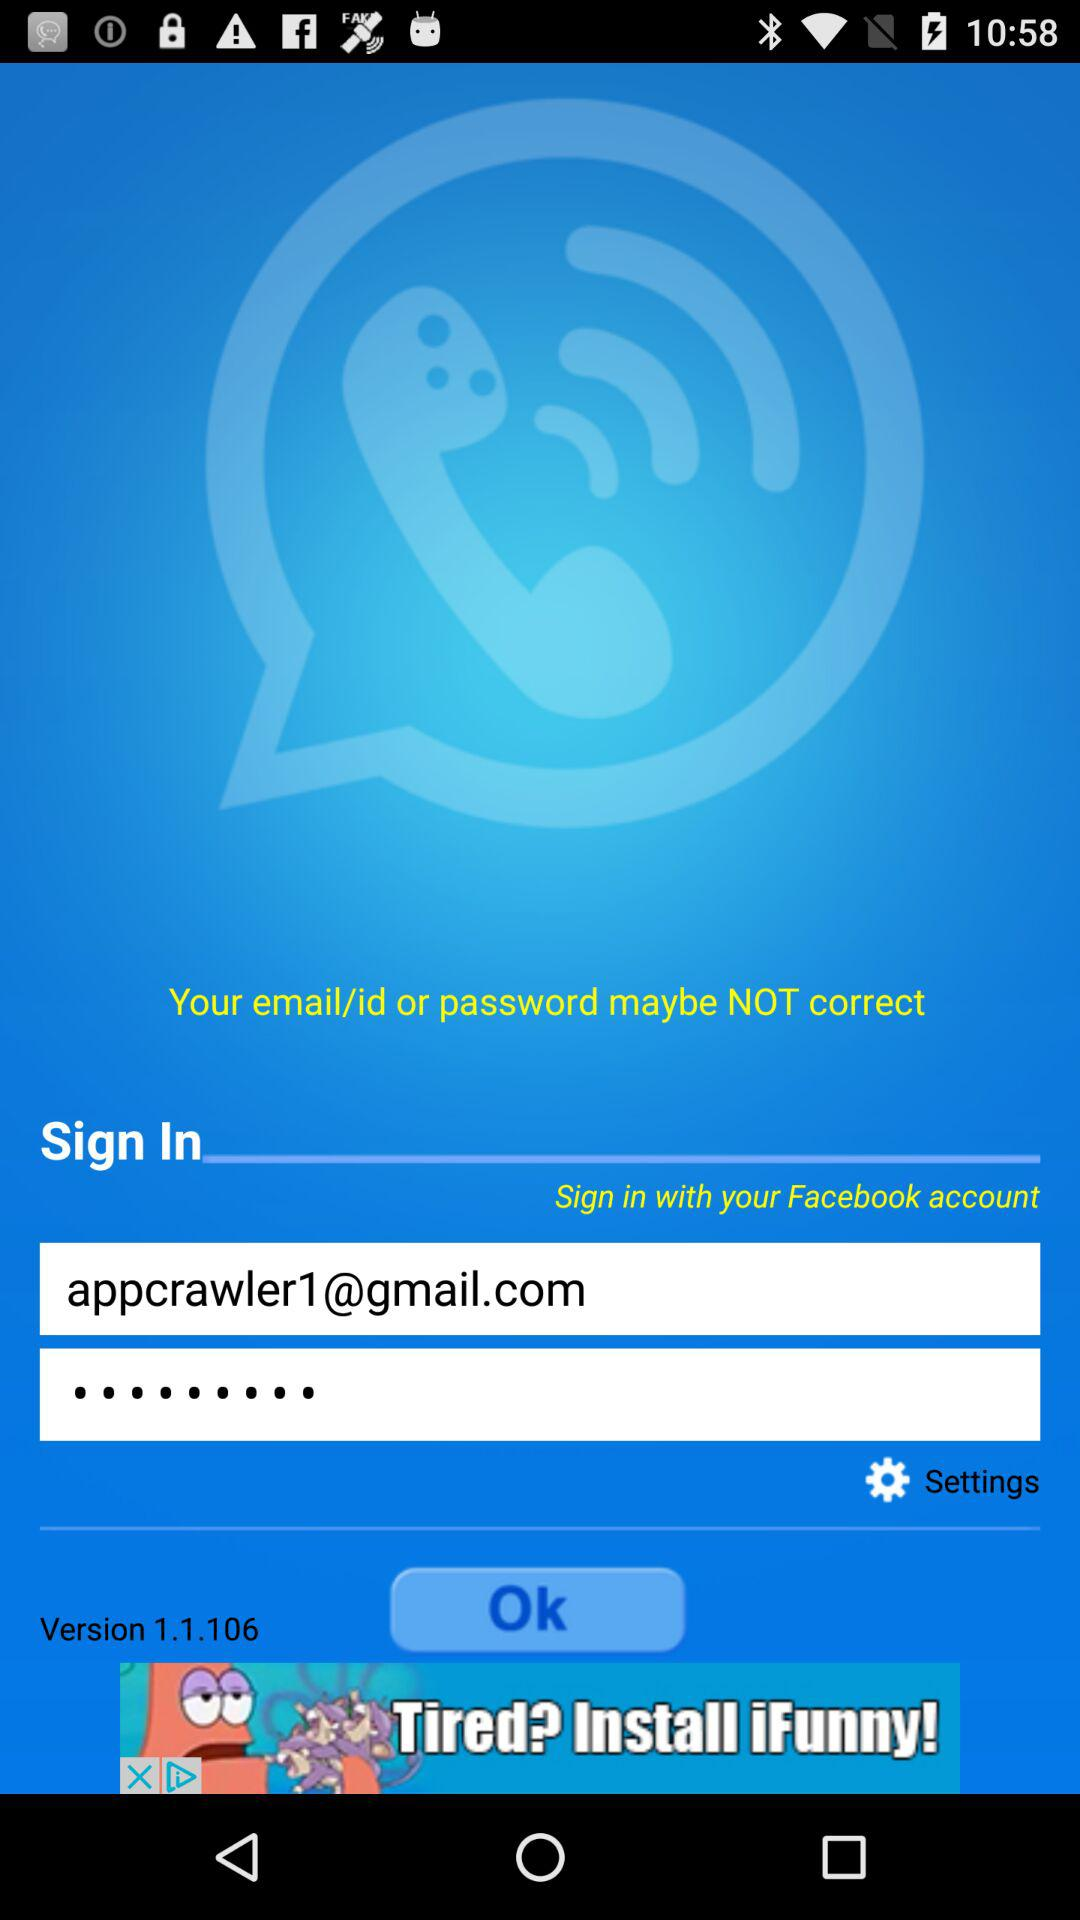How many text inputs are for email or phone?
Answer the question using a single word or phrase. 1 